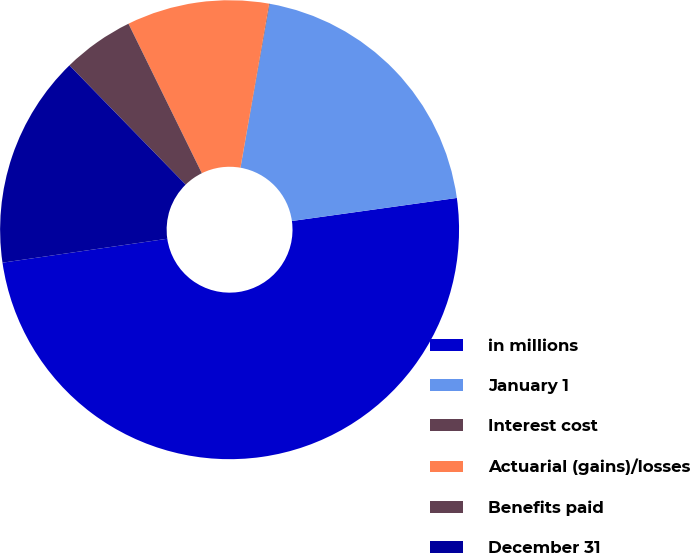Convert chart to OTSL. <chart><loc_0><loc_0><loc_500><loc_500><pie_chart><fcel>in millions<fcel>January 1<fcel>Interest cost<fcel>Actuarial (gains)/losses<fcel>Benefits paid<fcel>December 31<nl><fcel>49.91%<fcel>19.99%<fcel>0.04%<fcel>10.02%<fcel>5.03%<fcel>15.0%<nl></chart> 